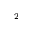Convert formula to latex. <formula><loc_0><loc_0><loc_500><loc_500>^ { 2 }</formula> 